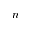Convert formula to latex. <formula><loc_0><loc_0><loc_500><loc_500>n</formula> 